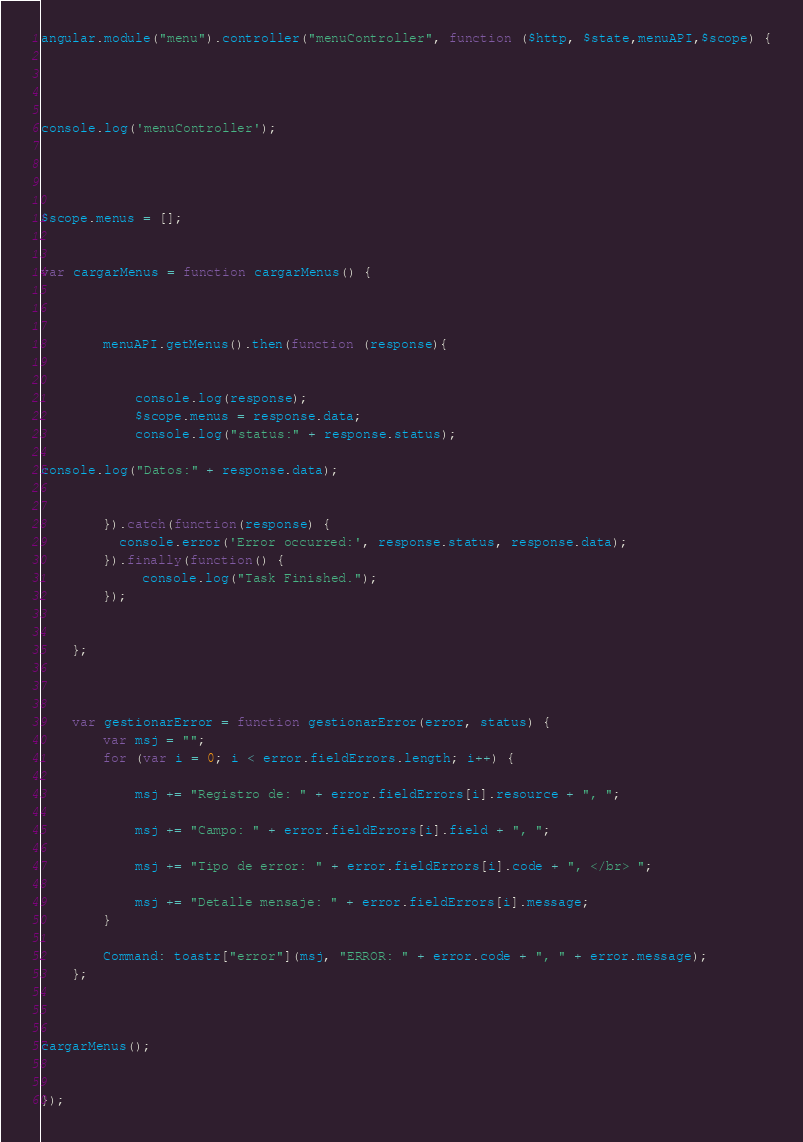<code> <loc_0><loc_0><loc_500><loc_500><_JavaScript_>angular.module("menu").controller("menuController", function ($http, $state,menuAPI,$scope) {




console.log('menuController');




$scope.menus = [];


var cargarMenus = function cargarMenus() {



		menuAPI.getMenus().then(function (response){


			console.log(response);
			$scope.menus = response.data;
			console.log("status:" + response.status);

console.log("Datos:" + response.data);


		}).catch(function(response) {
		  console.error('Error occurred:', response.status, response.data);
		}).finally(function() {
			 console.log("Task Finished.");
		});

		
	};



	var gestionarError = function gestionarError(error, status) {
		var msj = "";
		for (var i = 0; i < error.fieldErrors.length; i++) {

			msj += "Registro de: " + error.fieldErrors[i].resource + ", ";

			msj += "Campo: " + error.fieldErrors[i].field + ", ";

			msj += "Tipo de error: " + error.fieldErrors[i].code + ", </br> ";

			msj += "Detalle mensaje: " + error.fieldErrors[i].message;
		}

		Command: toastr["error"](msj, "ERROR: " + error.code + ", " + error.message);
	};



cargarMenus();


});</code> 